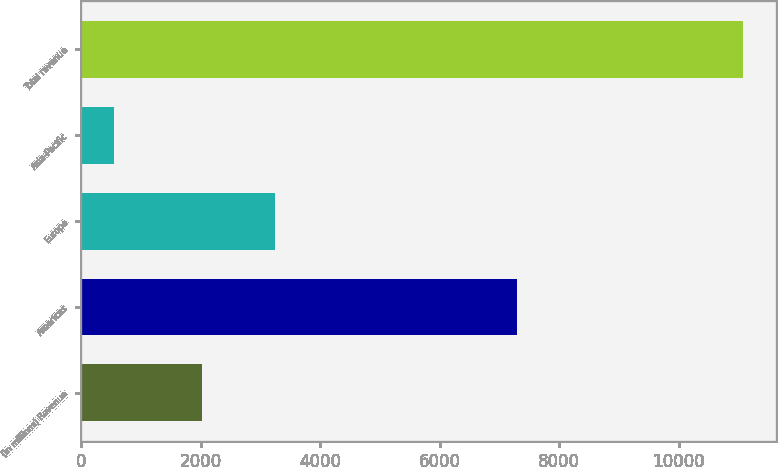Convert chart to OTSL. <chart><loc_0><loc_0><loc_500><loc_500><bar_chart><fcel>(in millions) Revenue<fcel>Americas<fcel>Europe<fcel>Asia-Pacific<fcel>Total revenue<nl><fcel>2014<fcel>7286<fcel>3246<fcel>549<fcel>11081<nl></chart> 